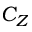<formula> <loc_0><loc_0><loc_500><loc_500>C _ { Z }</formula> 